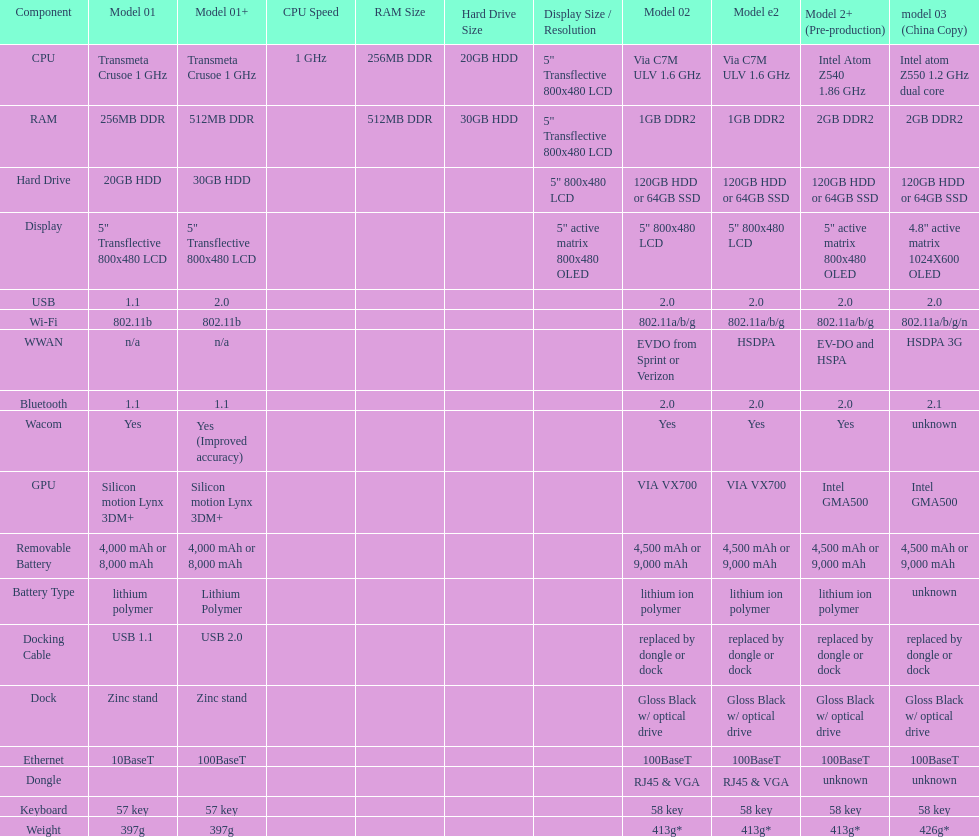What is the component before usb? Display. 